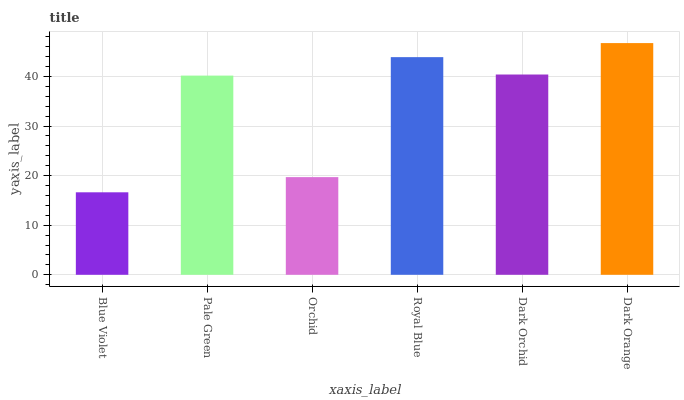Is Blue Violet the minimum?
Answer yes or no. Yes. Is Dark Orange the maximum?
Answer yes or no. Yes. Is Pale Green the minimum?
Answer yes or no. No. Is Pale Green the maximum?
Answer yes or no. No. Is Pale Green greater than Blue Violet?
Answer yes or no. Yes. Is Blue Violet less than Pale Green?
Answer yes or no. Yes. Is Blue Violet greater than Pale Green?
Answer yes or no. No. Is Pale Green less than Blue Violet?
Answer yes or no. No. Is Dark Orchid the high median?
Answer yes or no. Yes. Is Pale Green the low median?
Answer yes or no. Yes. Is Dark Orange the high median?
Answer yes or no. No. Is Blue Violet the low median?
Answer yes or no. No. 